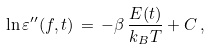<formula> <loc_0><loc_0><loc_500><loc_500>\ln \varepsilon ^ { \prime \prime } ( f , t ) \, = \, - \beta \, \frac { E ( t ) } { k _ { B } T } + C \, ,</formula> 